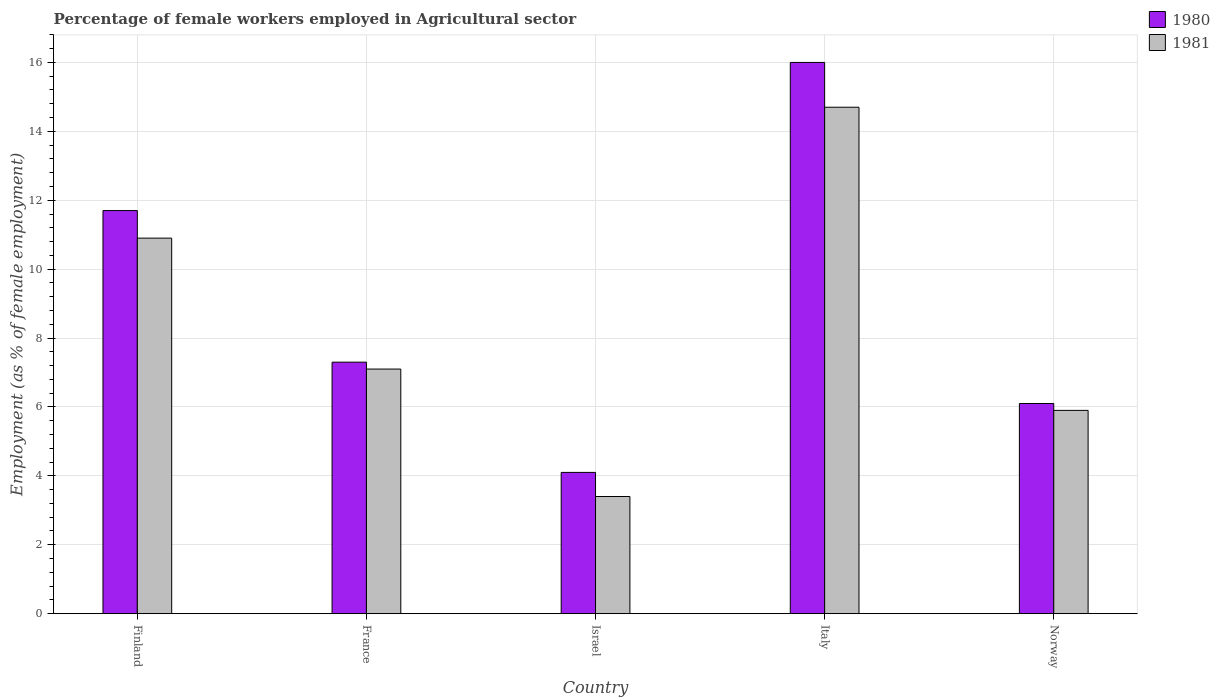What is the percentage of females employed in Agricultural sector in 1981 in Italy?
Make the answer very short. 14.7. Across all countries, what is the maximum percentage of females employed in Agricultural sector in 1981?
Offer a terse response. 14.7. Across all countries, what is the minimum percentage of females employed in Agricultural sector in 1981?
Your answer should be very brief. 3.4. In which country was the percentage of females employed in Agricultural sector in 1981 maximum?
Your answer should be compact. Italy. What is the total percentage of females employed in Agricultural sector in 1980 in the graph?
Your answer should be compact. 45.2. What is the difference between the percentage of females employed in Agricultural sector in 1981 in Finland and that in Israel?
Your answer should be compact. 7.5. What is the difference between the percentage of females employed in Agricultural sector in 1981 in France and the percentage of females employed in Agricultural sector in 1980 in Finland?
Offer a very short reply. -4.6. What is the average percentage of females employed in Agricultural sector in 1980 per country?
Your response must be concise. 9.04. What is the difference between the percentage of females employed in Agricultural sector of/in 1980 and percentage of females employed in Agricultural sector of/in 1981 in Finland?
Provide a short and direct response. 0.8. In how many countries, is the percentage of females employed in Agricultural sector in 1981 greater than 12.8 %?
Ensure brevity in your answer.  1. What is the ratio of the percentage of females employed in Agricultural sector in 1980 in Israel to that in Italy?
Your answer should be compact. 0.26. Is the percentage of females employed in Agricultural sector in 1980 in France less than that in Norway?
Your answer should be very brief. No. Is the difference between the percentage of females employed in Agricultural sector in 1980 in Italy and Norway greater than the difference between the percentage of females employed in Agricultural sector in 1981 in Italy and Norway?
Keep it short and to the point. Yes. What is the difference between the highest and the second highest percentage of females employed in Agricultural sector in 1981?
Offer a terse response. -3.8. What is the difference between the highest and the lowest percentage of females employed in Agricultural sector in 1981?
Ensure brevity in your answer.  11.3. Is the sum of the percentage of females employed in Agricultural sector in 1981 in Israel and Norway greater than the maximum percentage of females employed in Agricultural sector in 1980 across all countries?
Provide a short and direct response. No. What does the 2nd bar from the left in Italy represents?
Your answer should be compact. 1981. How many bars are there?
Your answer should be very brief. 10. How many countries are there in the graph?
Keep it short and to the point. 5. Does the graph contain any zero values?
Provide a short and direct response. No. How many legend labels are there?
Offer a very short reply. 2. What is the title of the graph?
Your answer should be compact. Percentage of female workers employed in Agricultural sector. What is the label or title of the X-axis?
Keep it short and to the point. Country. What is the label or title of the Y-axis?
Make the answer very short. Employment (as % of female employment). What is the Employment (as % of female employment) of 1980 in Finland?
Your answer should be compact. 11.7. What is the Employment (as % of female employment) of 1981 in Finland?
Give a very brief answer. 10.9. What is the Employment (as % of female employment) of 1980 in France?
Give a very brief answer. 7.3. What is the Employment (as % of female employment) of 1981 in France?
Offer a very short reply. 7.1. What is the Employment (as % of female employment) in 1980 in Israel?
Ensure brevity in your answer.  4.1. What is the Employment (as % of female employment) of 1981 in Israel?
Your response must be concise. 3.4. What is the Employment (as % of female employment) in 1980 in Italy?
Keep it short and to the point. 16. What is the Employment (as % of female employment) in 1981 in Italy?
Ensure brevity in your answer.  14.7. What is the Employment (as % of female employment) in 1980 in Norway?
Offer a terse response. 6.1. What is the Employment (as % of female employment) of 1981 in Norway?
Give a very brief answer. 5.9. Across all countries, what is the maximum Employment (as % of female employment) of 1980?
Offer a very short reply. 16. Across all countries, what is the maximum Employment (as % of female employment) of 1981?
Offer a terse response. 14.7. Across all countries, what is the minimum Employment (as % of female employment) in 1980?
Offer a very short reply. 4.1. Across all countries, what is the minimum Employment (as % of female employment) of 1981?
Your response must be concise. 3.4. What is the total Employment (as % of female employment) of 1980 in the graph?
Your response must be concise. 45.2. What is the total Employment (as % of female employment) of 1981 in the graph?
Make the answer very short. 42. What is the difference between the Employment (as % of female employment) of 1981 in Finland and that in Israel?
Give a very brief answer. 7.5. What is the difference between the Employment (as % of female employment) in 1981 in Finland and that in Italy?
Your answer should be very brief. -3.8. What is the difference between the Employment (as % of female employment) in 1981 in France and that in Israel?
Your answer should be compact. 3.7. What is the difference between the Employment (as % of female employment) in 1981 in France and that in Italy?
Provide a succinct answer. -7.6. What is the difference between the Employment (as % of female employment) in 1981 in Israel and that in Norway?
Offer a terse response. -2.5. What is the difference between the Employment (as % of female employment) of 1980 in Finland and the Employment (as % of female employment) of 1981 in France?
Make the answer very short. 4.6. What is the difference between the Employment (as % of female employment) of 1980 in Finland and the Employment (as % of female employment) of 1981 in Israel?
Ensure brevity in your answer.  8.3. What is the difference between the Employment (as % of female employment) in 1980 in Finland and the Employment (as % of female employment) in 1981 in Italy?
Provide a succinct answer. -3. What is the difference between the Employment (as % of female employment) in 1980 in Finland and the Employment (as % of female employment) in 1981 in Norway?
Give a very brief answer. 5.8. What is the difference between the Employment (as % of female employment) of 1980 in France and the Employment (as % of female employment) of 1981 in Norway?
Ensure brevity in your answer.  1.4. What is the difference between the Employment (as % of female employment) of 1980 in Italy and the Employment (as % of female employment) of 1981 in Norway?
Ensure brevity in your answer.  10.1. What is the average Employment (as % of female employment) in 1980 per country?
Ensure brevity in your answer.  9.04. What is the average Employment (as % of female employment) in 1981 per country?
Make the answer very short. 8.4. What is the difference between the Employment (as % of female employment) of 1980 and Employment (as % of female employment) of 1981 in Italy?
Your answer should be compact. 1.3. What is the difference between the Employment (as % of female employment) in 1980 and Employment (as % of female employment) in 1981 in Norway?
Make the answer very short. 0.2. What is the ratio of the Employment (as % of female employment) in 1980 in Finland to that in France?
Your response must be concise. 1.6. What is the ratio of the Employment (as % of female employment) of 1981 in Finland to that in France?
Give a very brief answer. 1.54. What is the ratio of the Employment (as % of female employment) of 1980 in Finland to that in Israel?
Offer a very short reply. 2.85. What is the ratio of the Employment (as % of female employment) of 1981 in Finland to that in Israel?
Offer a very short reply. 3.21. What is the ratio of the Employment (as % of female employment) of 1980 in Finland to that in Italy?
Your answer should be very brief. 0.73. What is the ratio of the Employment (as % of female employment) of 1981 in Finland to that in Italy?
Your answer should be compact. 0.74. What is the ratio of the Employment (as % of female employment) in 1980 in Finland to that in Norway?
Give a very brief answer. 1.92. What is the ratio of the Employment (as % of female employment) of 1981 in Finland to that in Norway?
Your answer should be compact. 1.85. What is the ratio of the Employment (as % of female employment) of 1980 in France to that in Israel?
Ensure brevity in your answer.  1.78. What is the ratio of the Employment (as % of female employment) in 1981 in France to that in Israel?
Offer a very short reply. 2.09. What is the ratio of the Employment (as % of female employment) of 1980 in France to that in Italy?
Make the answer very short. 0.46. What is the ratio of the Employment (as % of female employment) in 1981 in France to that in Italy?
Make the answer very short. 0.48. What is the ratio of the Employment (as % of female employment) of 1980 in France to that in Norway?
Your answer should be very brief. 1.2. What is the ratio of the Employment (as % of female employment) of 1981 in France to that in Norway?
Provide a short and direct response. 1.2. What is the ratio of the Employment (as % of female employment) of 1980 in Israel to that in Italy?
Make the answer very short. 0.26. What is the ratio of the Employment (as % of female employment) in 1981 in Israel to that in Italy?
Offer a terse response. 0.23. What is the ratio of the Employment (as % of female employment) in 1980 in Israel to that in Norway?
Your answer should be compact. 0.67. What is the ratio of the Employment (as % of female employment) of 1981 in Israel to that in Norway?
Give a very brief answer. 0.58. What is the ratio of the Employment (as % of female employment) in 1980 in Italy to that in Norway?
Your answer should be very brief. 2.62. What is the ratio of the Employment (as % of female employment) of 1981 in Italy to that in Norway?
Give a very brief answer. 2.49. What is the difference between the highest and the lowest Employment (as % of female employment) of 1980?
Your response must be concise. 11.9. 